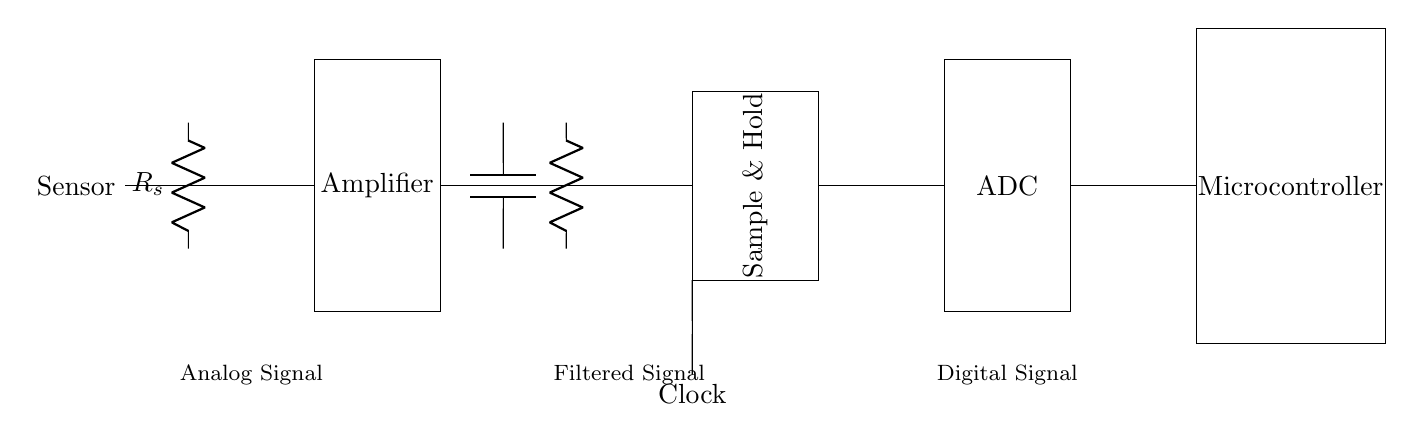What type of sensor is being used? The diagram labels the first component as "Sensor," indicating that it interfaces with the analog input signal. However, the specific type is not detailed in the circuit.
Answer: Sensor What is the function of the amplifier in the circuit? The amplifier is used to increase the amplitude of the analog signal coming from the sensor, preparing it for further processing.
Answer: Increase amplitude What component follows the low-pass filter? After the low-pass filter, the next component is the sample and hold circuit, which captures the filtered signal for digitization.
Answer: Sample and Hold How many main components are there in the circuit? The main components include a sensor, amplifier, low-pass filter, sample and hold, ADC, and microcontroller, totaling six components in the circuit.
Answer: Six What is the purpose of the clock in this circuit? The clock signal coordinates the timing of the sample and hold, ensuring that the analog signal is captured at specific intervals for accurate conversion to digital.
Answer: Timing control What type of converter is indicated in the circuit? The diagram specifically mentions "ADC," which stands for analog-to-digital converter, explaining that this component converts the analog signal into a digital form.
Answer: ADC 